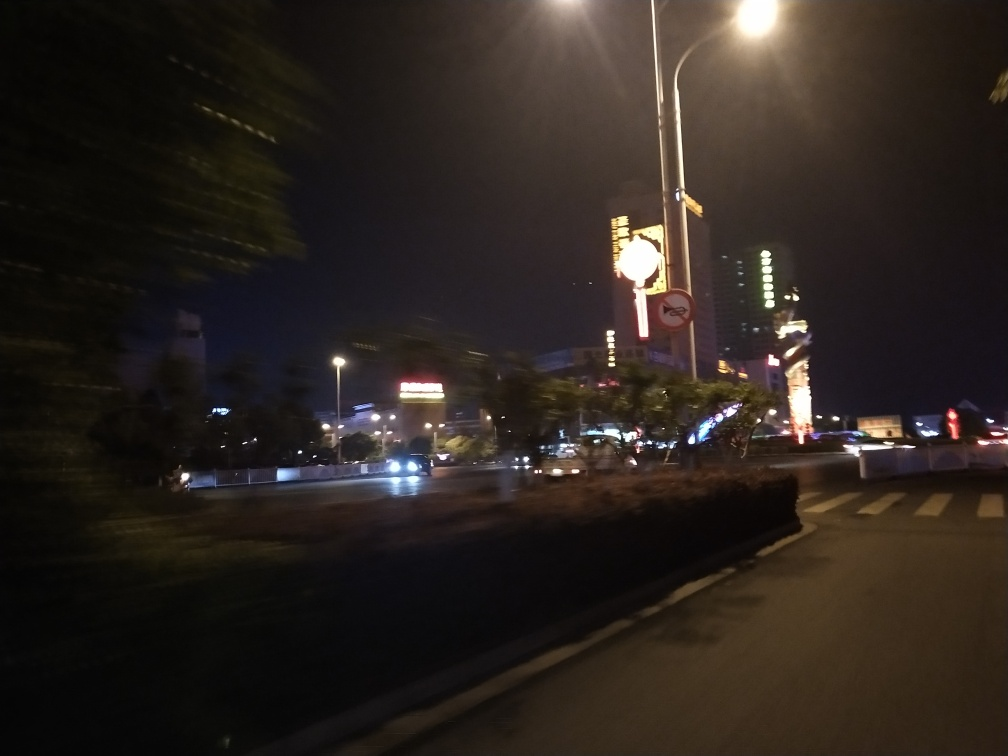How would you describe the ambiance or mood of this scene? The ambiance of the scene is dynamic yet slightly obscured, evoking a sense of motion and nocturnal city life. The streaking lights and blurred surroundings create a feeling of rapid movement, possibly reflecting the hustle and bustle of urban existence after dusk. The bright lights and advertisements add vibrancy to the scene, suggesting an area replete with activity and commerce. 